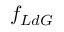<formula> <loc_0><loc_0><loc_500><loc_500>f _ { L d G }</formula> 